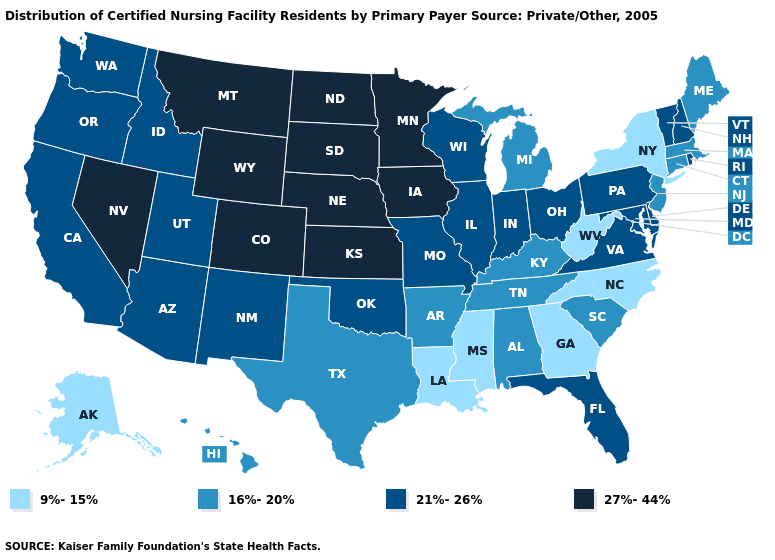Name the states that have a value in the range 27%-44%?
Give a very brief answer. Colorado, Iowa, Kansas, Minnesota, Montana, Nebraska, Nevada, North Dakota, South Dakota, Wyoming. What is the value of Florida?
Give a very brief answer. 21%-26%. Name the states that have a value in the range 16%-20%?
Quick response, please. Alabama, Arkansas, Connecticut, Hawaii, Kentucky, Maine, Massachusetts, Michigan, New Jersey, South Carolina, Tennessee, Texas. Among the states that border Delaware , which have the highest value?
Answer briefly. Maryland, Pennsylvania. What is the lowest value in states that border California?
Quick response, please. 21%-26%. What is the value of South Carolina?
Give a very brief answer. 16%-20%. What is the value of Arkansas?
Keep it brief. 16%-20%. Name the states that have a value in the range 16%-20%?
Short answer required. Alabama, Arkansas, Connecticut, Hawaii, Kentucky, Maine, Massachusetts, Michigan, New Jersey, South Carolina, Tennessee, Texas. How many symbols are there in the legend?
Concise answer only. 4. Among the states that border Montana , does South Dakota have the highest value?
Quick response, please. Yes. Does Florida have the lowest value in the South?
Answer briefly. No. Among the states that border Mississippi , which have the lowest value?
Concise answer only. Louisiana. Name the states that have a value in the range 9%-15%?
Keep it brief. Alaska, Georgia, Louisiana, Mississippi, New York, North Carolina, West Virginia. Name the states that have a value in the range 9%-15%?
Give a very brief answer. Alaska, Georgia, Louisiana, Mississippi, New York, North Carolina, West Virginia. Does Michigan have a lower value than Kentucky?
Quick response, please. No. 